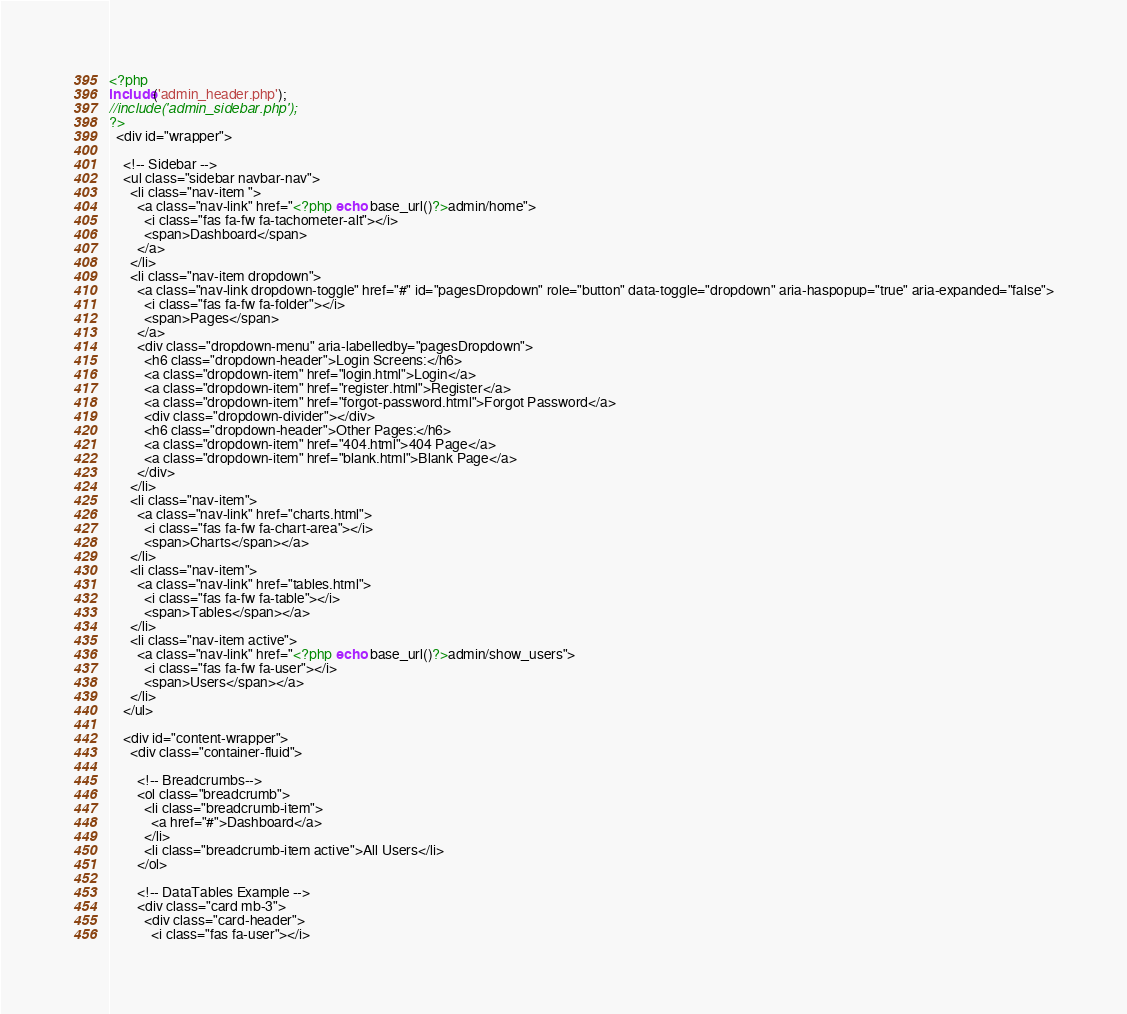Convert code to text. <code><loc_0><loc_0><loc_500><loc_500><_PHP_><?php 
include('admin_header.php');
//include('admin_sidebar.php');
?>
  <div id="wrapper">

    <!-- Sidebar -->
    <ul class="sidebar navbar-nav">
      <li class="nav-item ">
        <a class="nav-link" href="<?php echo base_url()?>admin/home">
          <i class="fas fa-fw fa-tachometer-alt"></i>
          <span>Dashboard</span>
        </a>
      </li>
      <li class="nav-item dropdown">
        <a class="nav-link dropdown-toggle" href="#" id="pagesDropdown" role="button" data-toggle="dropdown" aria-haspopup="true" aria-expanded="false">
          <i class="fas fa-fw fa-folder"></i>
          <span>Pages</span>
        </a>
        <div class="dropdown-menu" aria-labelledby="pagesDropdown">
          <h6 class="dropdown-header">Login Screens:</h6>
          <a class="dropdown-item" href="login.html">Login</a>
          <a class="dropdown-item" href="register.html">Register</a>
          <a class="dropdown-item" href="forgot-password.html">Forgot Password</a>
          <div class="dropdown-divider"></div>
          <h6 class="dropdown-header">Other Pages:</h6>
          <a class="dropdown-item" href="404.html">404 Page</a>
          <a class="dropdown-item" href="blank.html">Blank Page</a>
        </div>
      </li>
      <li class="nav-item">
        <a class="nav-link" href="charts.html">
          <i class="fas fa-fw fa-chart-area"></i>
          <span>Charts</span></a>
      </li>
      <li class="nav-item">
        <a class="nav-link" href="tables.html">
          <i class="fas fa-fw fa-table"></i>
          <span>Tables</span></a>
      </li>
      <li class="nav-item active">
        <a class="nav-link" href="<?php echo base_url()?>admin/show_users">
          <i class="fas fa-fw fa-user"></i>
          <span>Users</span></a>
      </li>
    </ul>

    <div id="content-wrapper">
      <div class="container-fluid">

        <!-- Breadcrumbs-->
        <ol class="breadcrumb">
          <li class="breadcrumb-item">
            <a href="#">Dashboard</a>
          </li>
          <li class="breadcrumb-item active">All Users</li>
        </ol>

        <!-- DataTables Example -->
        <div class="card mb-3">
          <div class="card-header">
            <i class="fas fa-user"></i></code> 